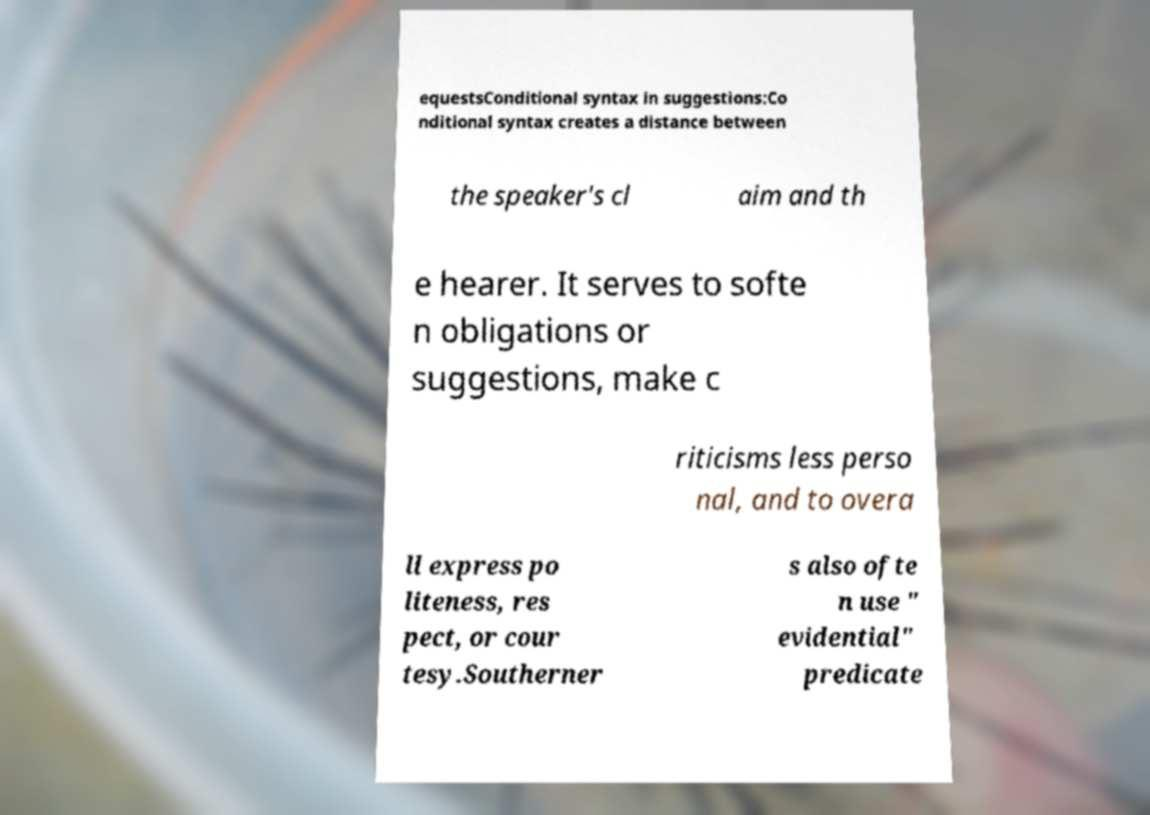Please identify and transcribe the text found in this image. equestsConditional syntax in suggestions:Co nditional syntax creates a distance between the speaker's cl aim and th e hearer. It serves to softe n obligations or suggestions, make c riticisms less perso nal, and to overa ll express po liteness, res pect, or cour tesy.Southerner s also ofte n use " evidential" predicate 